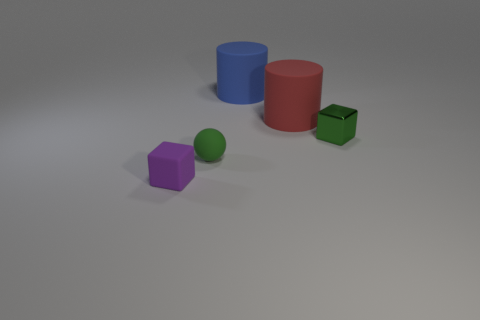Add 3 large objects. How many objects exist? 8 Subtract all cylinders. How many objects are left? 3 Add 4 small purple things. How many small purple things exist? 5 Subtract 1 blue cylinders. How many objects are left? 4 Subtract all purple objects. Subtract all spheres. How many objects are left? 3 Add 3 rubber blocks. How many rubber blocks are left? 4 